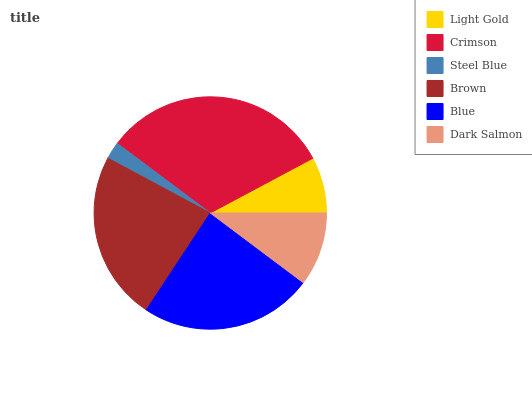Is Steel Blue the minimum?
Answer yes or no. Yes. Is Crimson the maximum?
Answer yes or no. Yes. Is Crimson the minimum?
Answer yes or no. No. Is Steel Blue the maximum?
Answer yes or no. No. Is Crimson greater than Steel Blue?
Answer yes or no. Yes. Is Steel Blue less than Crimson?
Answer yes or no. Yes. Is Steel Blue greater than Crimson?
Answer yes or no. No. Is Crimson less than Steel Blue?
Answer yes or no. No. Is Brown the high median?
Answer yes or no. Yes. Is Dark Salmon the low median?
Answer yes or no. Yes. Is Light Gold the high median?
Answer yes or no. No. Is Brown the low median?
Answer yes or no. No. 